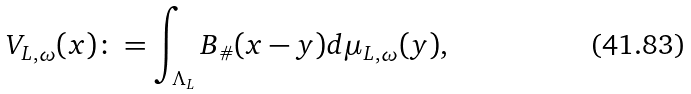<formula> <loc_0><loc_0><loc_500><loc_500>V _ { L , \omega } ( x ) \colon = \int _ { \Lambda _ { L } } B _ { \# } ( x - y ) d \mu _ { L , \omega } ( y ) ,</formula> 